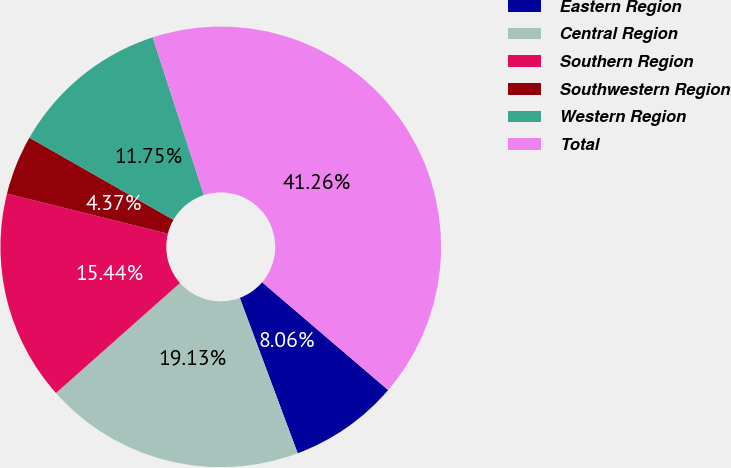<chart> <loc_0><loc_0><loc_500><loc_500><pie_chart><fcel>Eastern Region<fcel>Central Region<fcel>Southern Region<fcel>Southwestern Region<fcel>Western Region<fcel>Total<nl><fcel>8.06%<fcel>19.13%<fcel>15.44%<fcel>4.37%<fcel>11.75%<fcel>41.27%<nl></chart> 